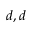Convert formula to latex. <formula><loc_0><loc_0><loc_500><loc_500>d , d</formula> 